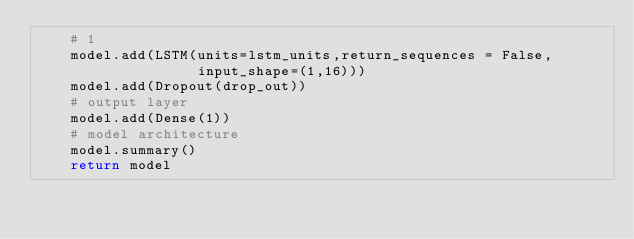<code> <loc_0><loc_0><loc_500><loc_500><_Python_>    # 1
    model.add(LSTM(units=lstm_units,return_sequences = False,
                   input_shape=(1,16)))
    model.add(Dropout(drop_out))
    # output layer
    model.add(Dense(1))
    # model architecture
    model.summary()
    return model

</code> 